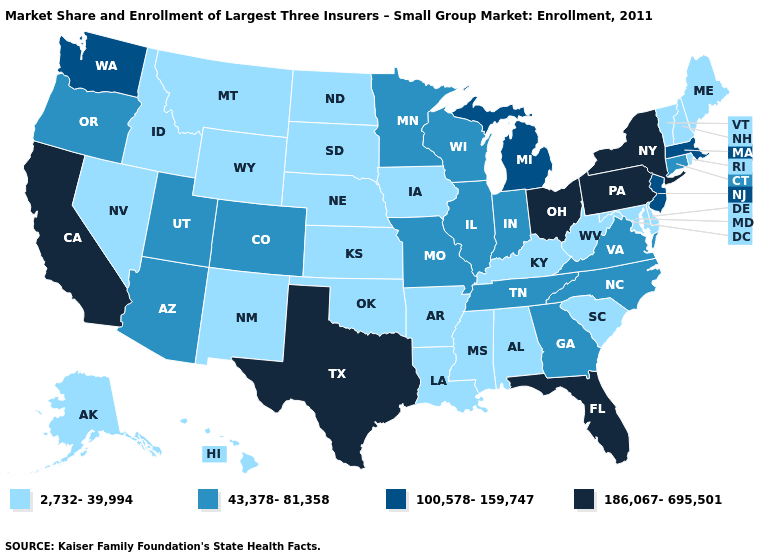Does the map have missing data?
Short answer required. No. How many symbols are there in the legend?
Write a very short answer. 4. Does the map have missing data?
Quick response, please. No. Among the states that border Mississippi , which have the lowest value?
Write a very short answer. Alabama, Arkansas, Louisiana. Name the states that have a value in the range 100,578-159,747?
Concise answer only. Massachusetts, Michigan, New Jersey, Washington. Does the map have missing data?
Concise answer only. No. Name the states that have a value in the range 2,732-39,994?
Short answer required. Alabama, Alaska, Arkansas, Delaware, Hawaii, Idaho, Iowa, Kansas, Kentucky, Louisiana, Maine, Maryland, Mississippi, Montana, Nebraska, Nevada, New Hampshire, New Mexico, North Dakota, Oklahoma, Rhode Island, South Carolina, South Dakota, Vermont, West Virginia, Wyoming. What is the lowest value in states that border Wisconsin?
Give a very brief answer. 2,732-39,994. Name the states that have a value in the range 2,732-39,994?
Answer briefly. Alabama, Alaska, Arkansas, Delaware, Hawaii, Idaho, Iowa, Kansas, Kentucky, Louisiana, Maine, Maryland, Mississippi, Montana, Nebraska, Nevada, New Hampshire, New Mexico, North Dakota, Oklahoma, Rhode Island, South Carolina, South Dakota, Vermont, West Virginia, Wyoming. What is the highest value in the Northeast ?
Quick response, please. 186,067-695,501. What is the lowest value in states that border Louisiana?
Give a very brief answer. 2,732-39,994. What is the value of Illinois?
Quick response, please. 43,378-81,358. Name the states that have a value in the range 186,067-695,501?
Write a very short answer. California, Florida, New York, Ohio, Pennsylvania, Texas. Among the states that border Pennsylvania , does Maryland have the highest value?
Give a very brief answer. No. Name the states that have a value in the range 186,067-695,501?
Be succinct. California, Florida, New York, Ohio, Pennsylvania, Texas. 